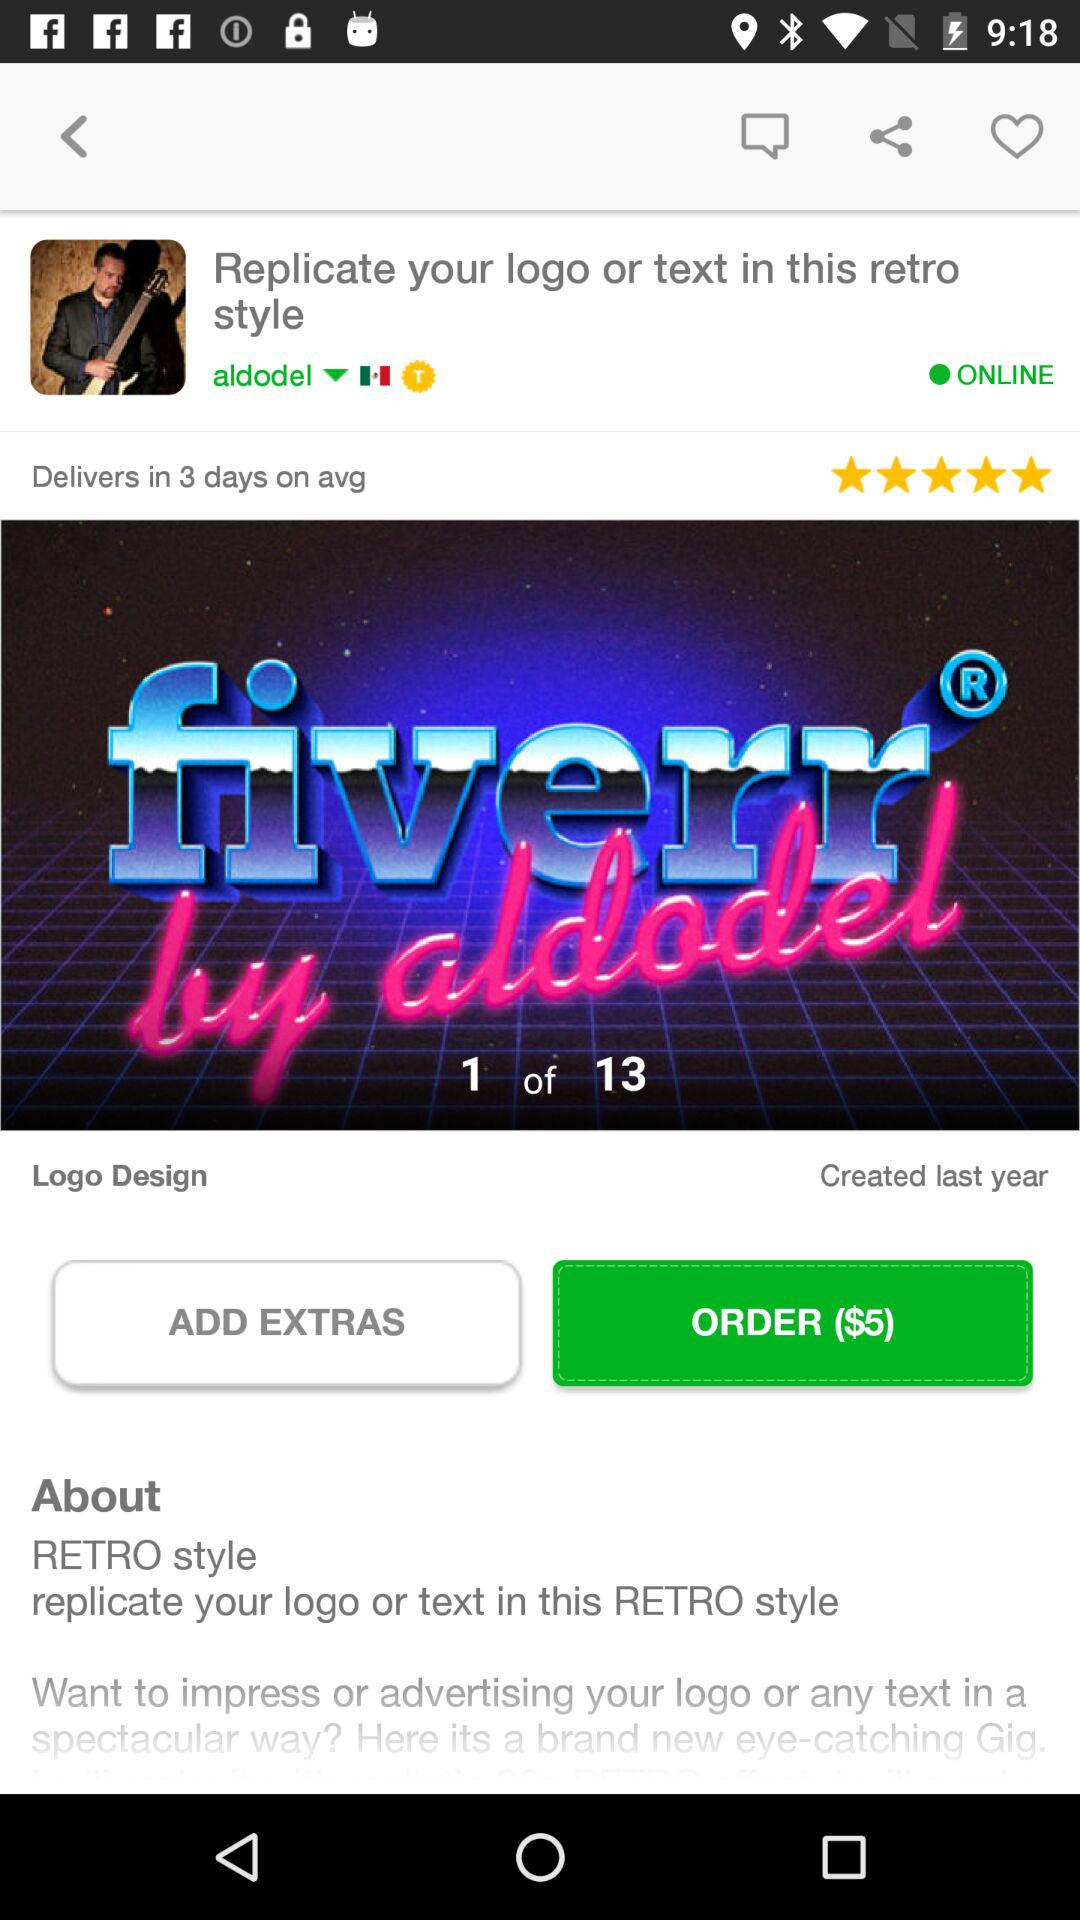How long does the delivery take on average? The delivery takes 3 days on average. 